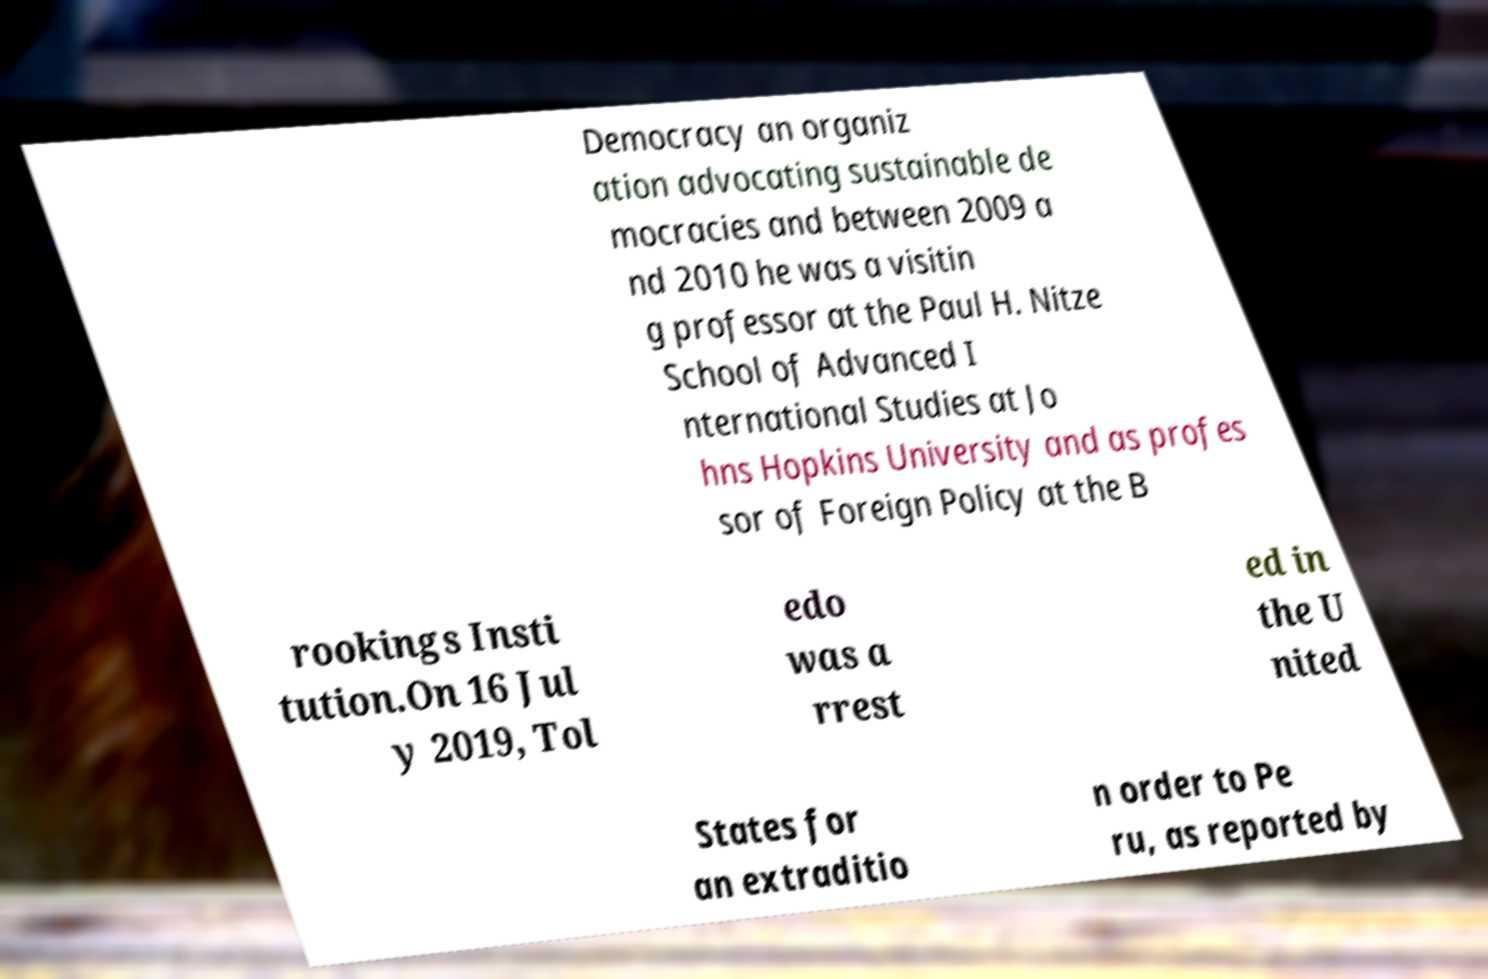Could you assist in decoding the text presented in this image and type it out clearly? Democracy an organiz ation advocating sustainable de mocracies and between 2009 a nd 2010 he was a visitin g professor at the Paul H. Nitze School of Advanced I nternational Studies at Jo hns Hopkins University and as profes sor of Foreign Policy at the B rookings Insti tution.On 16 Jul y 2019, Tol edo was a rrest ed in the U nited States for an extraditio n order to Pe ru, as reported by 